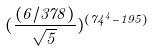Convert formula to latex. <formula><loc_0><loc_0><loc_500><loc_500>( \frac { ( 6 / 3 7 8 ) } { \sqrt { 5 } } ) ^ { ( 7 4 ^ { 4 } - 1 9 5 ) }</formula> 